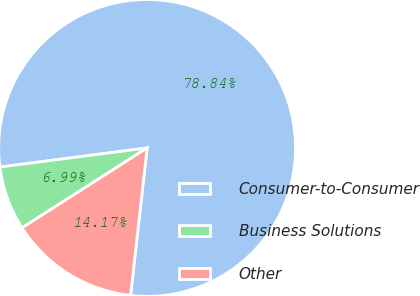Convert chart. <chart><loc_0><loc_0><loc_500><loc_500><pie_chart><fcel>Consumer-to-Consumer<fcel>Business Solutions<fcel>Other<nl><fcel>78.84%<fcel>6.99%<fcel>14.17%<nl></chart> 